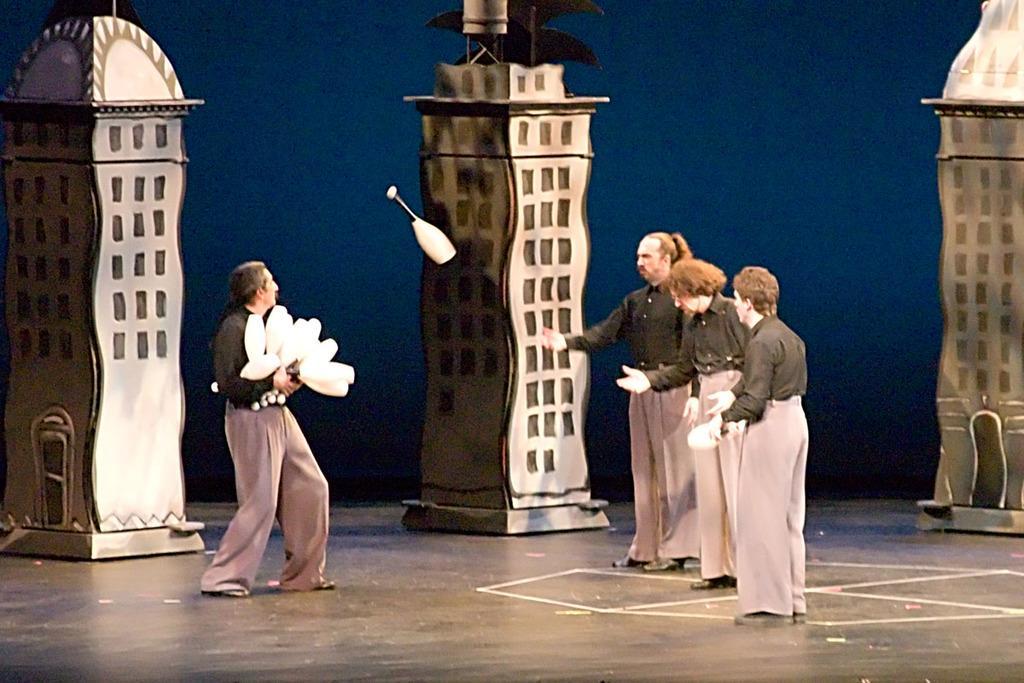In one or two sentences, can you explain what this image depicts? In this image there are a few people playing an act on the stage, one of them is holding some objects in his hand, there are a few depictions of buildings. In the background there is the wall. 